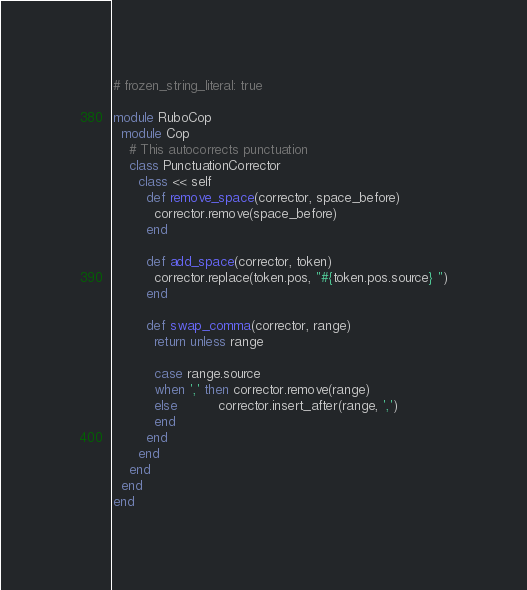Convert code to text. <code><loc_0><loc_0><loc_500><loc_500><_Ruby_># frozen_string_literal: true

module RuboCop
  module Cop
    # This autocorrects punctuation
    class PunctuationCorrector
      class << self
        def remove_space(corrector, space_before)
          corrector.remove(space_before)
        end

        def add_space(corrector, token)
          corrector.replace(token.pos, "#{token.pos.source} ")
        end

        def swap_comma(corrector, range)
          return unless range

          case range.source
          when ',' then corrector.remove(range)
          else          corrector.insert_after(range, ',')
          end
        end
      end
    end
  end
end
</code> 